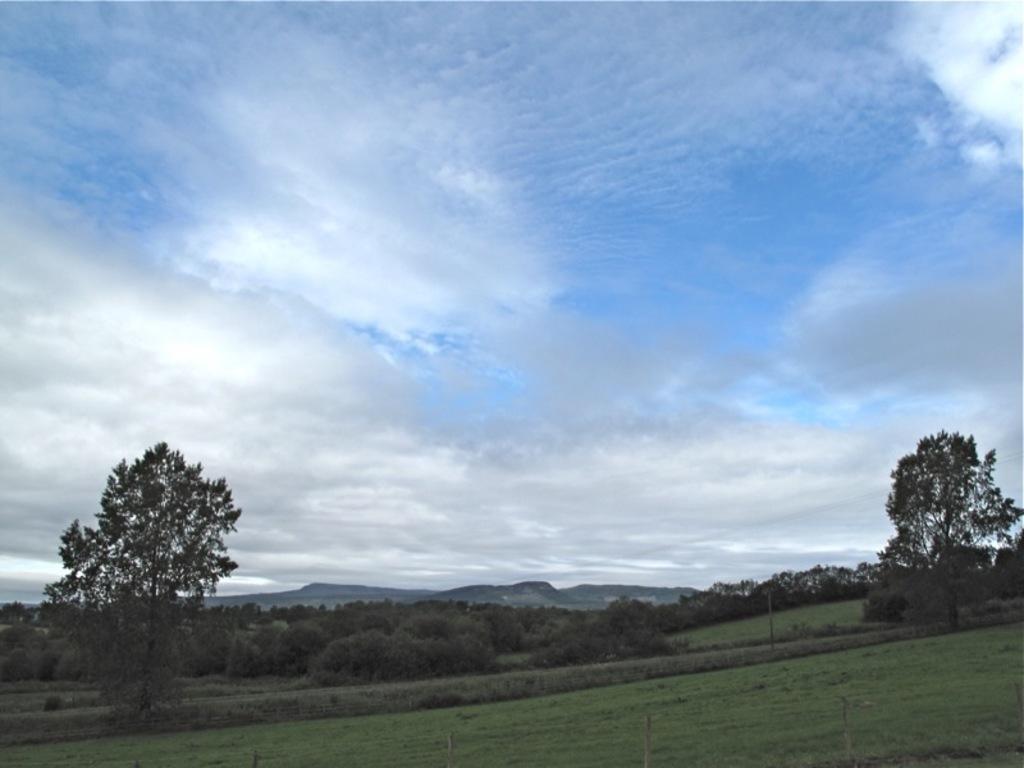How would you summarize this image in a sentence or two? There is a meadow. In the back there are trees and sky with clouds. 